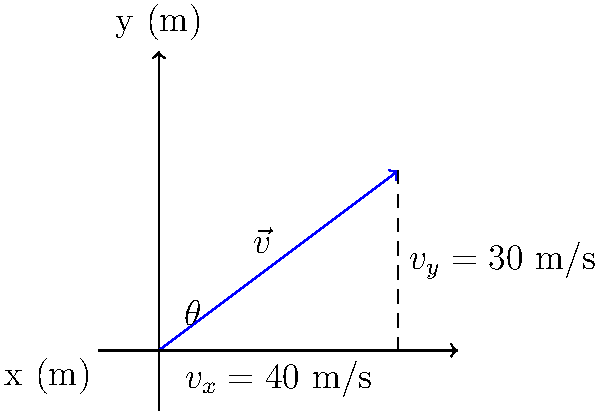A baseball is hit with an initial velocity vector $\vec{v}$ as shown in the diagram. If the magnitude of the velocity is 50 m/s, what is the angle $\theta$ at which the ball is hit relative to the horizontal? To find the angle $\theta$, we can use the trigonometric relationships in a right triangle formed by the velocity vector and its components. Here's how we can solve this step-by-step:

1) We're given that the magnitude of the velocity vector is 50 m/s.

2) From the diagram, we can see that the x-component ($v_x$) is 40 m/s and the y-component ($v_y$) is 30 m/s.

3) We can use the arctangent function to find the angle. The tangent of an angle is the ratio of the opposite side to the adjacent side in a right triangle. In this case:

   $\tan(\theta) = \frac{v_y}{v_x} = \frac{30}{40} = 0.75$

4) To find $\theta$, we take the inverse tangent (arctangent) of this ratio:

   $\theta = \arctan(0.75)$

5) Using a calculator or computer, we can find that:

   $\theta \approx 36.87°$

6) We can verify this using the Pythagorean theorem:

   $v^2 = v_x^2 + v_y^2$
   $50^2 = 40^2 + 30^2$
   $2500 = 1600 + 900 = 2500$

This confirms that our angle is correct, as it satisfies the known components and magnitude of the velocity vector.
Answer: $36.87°$ 